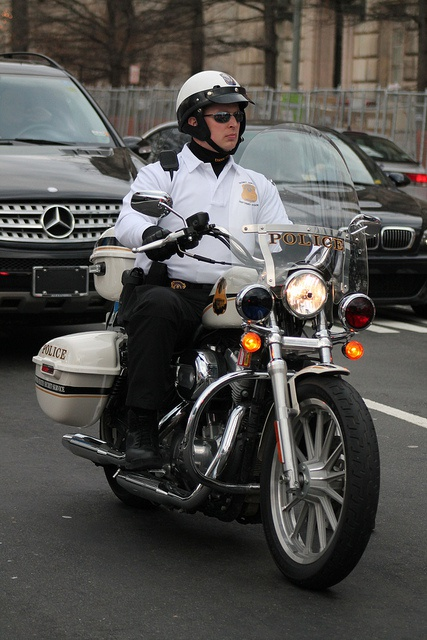Describe the objects in this image and their specific colors. I can see motorcycle in gray, black, darkgray, and lightgray tones, people in gray, black, lightgray, and darkgray tones, car in gray, black, and darkgray tones, car in gray, black, and darkgray tones, and car in gray, black, and darkgray tones in this image. 